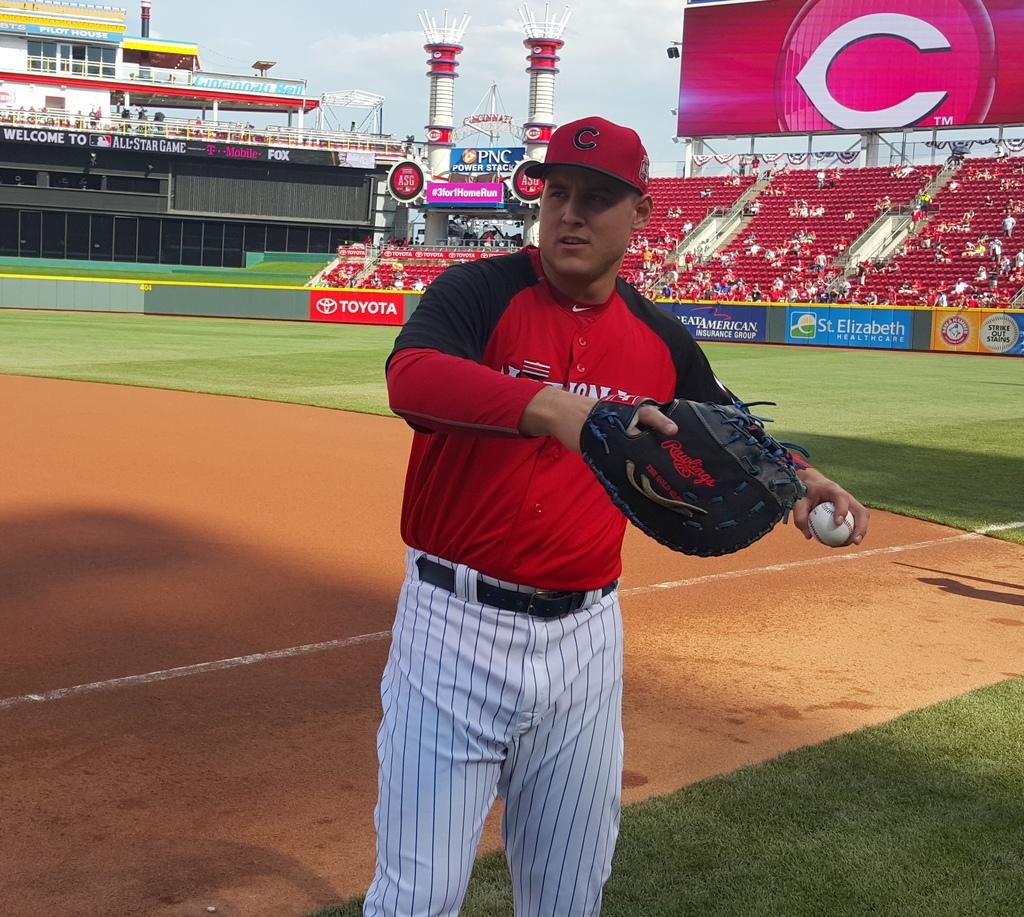Provide a one-sentence caption for the provided image. Pilot house in the background of the reds stadium. 